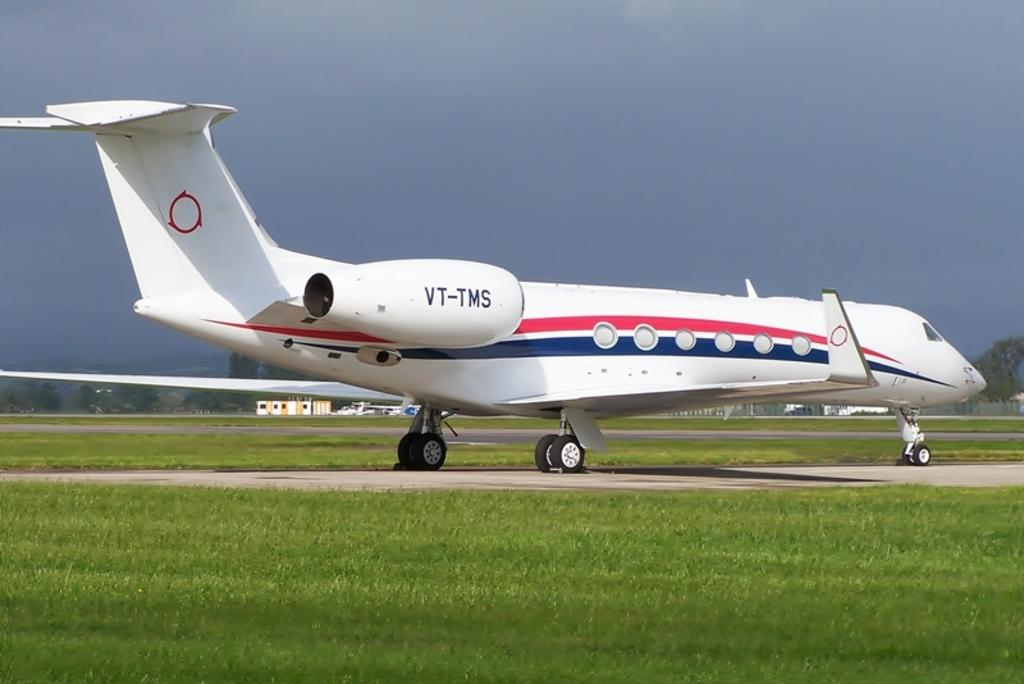Provide a one-sentence caption for the provided image. A red white and blue airplane with VT-TMS on it. 